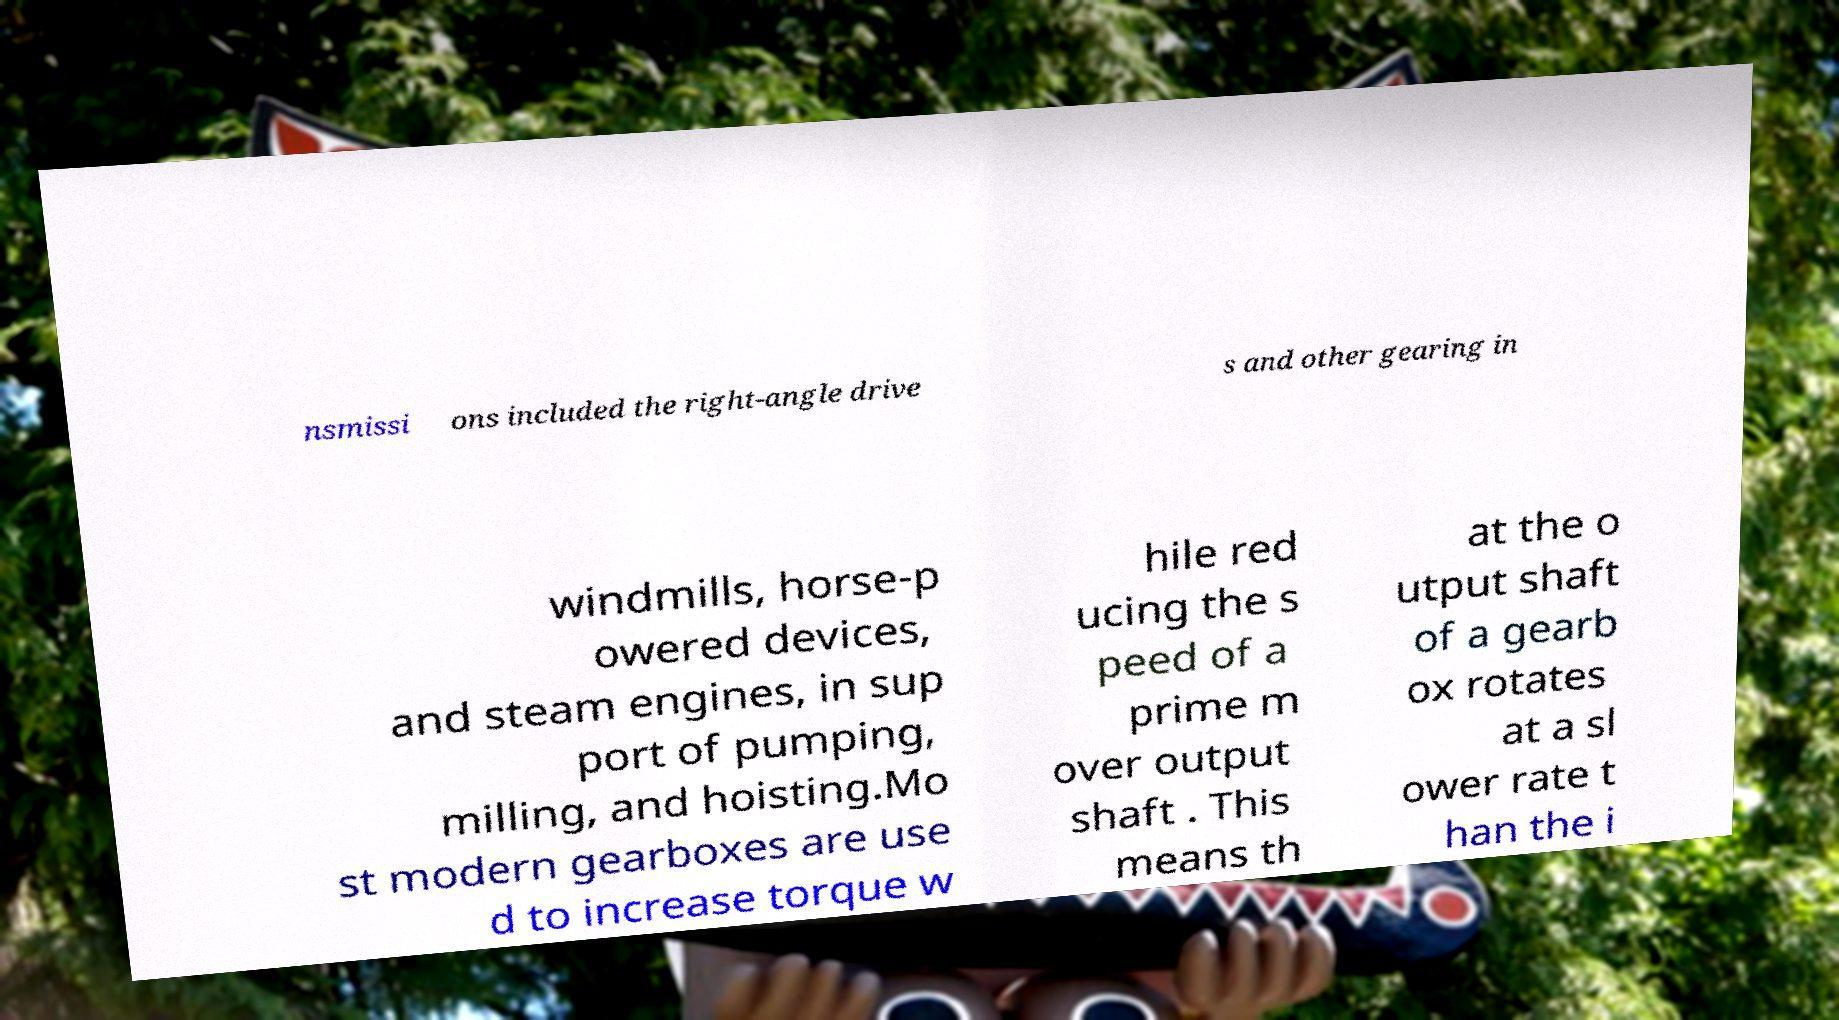Could you extract and type out the text from this image? nsmissi ons included the right-angle drive s and other gearing in windmills, horse-p owered devices, and steam engines, in sup port of pumping, milling, and hoisting.Mo st modern gearboxes are use d to increase torque w hile red ucing the s peed of a prime m over output shaft . This means th at the o utput shaft of a gearb ox rotates at a sl ower rate t han the i 